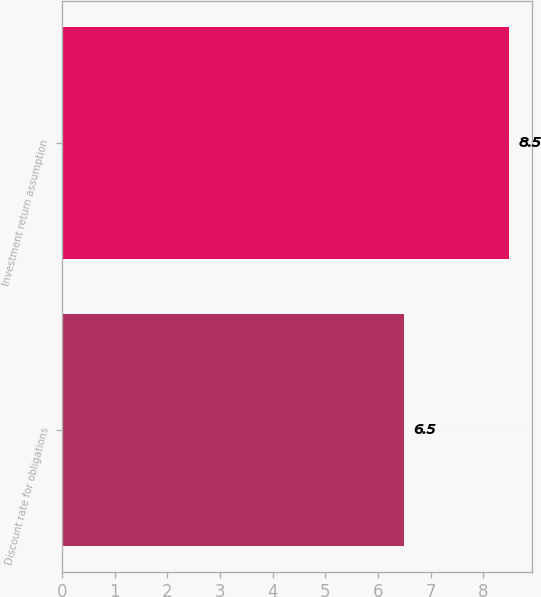<chart> <loc_0><loc_0><loc_500><loc_500><bar_chart><fcel>Discount rate for obligations<fcel>Investment return assumption<nl><fcel>6.5<fcel>8.5<nl></chart> 